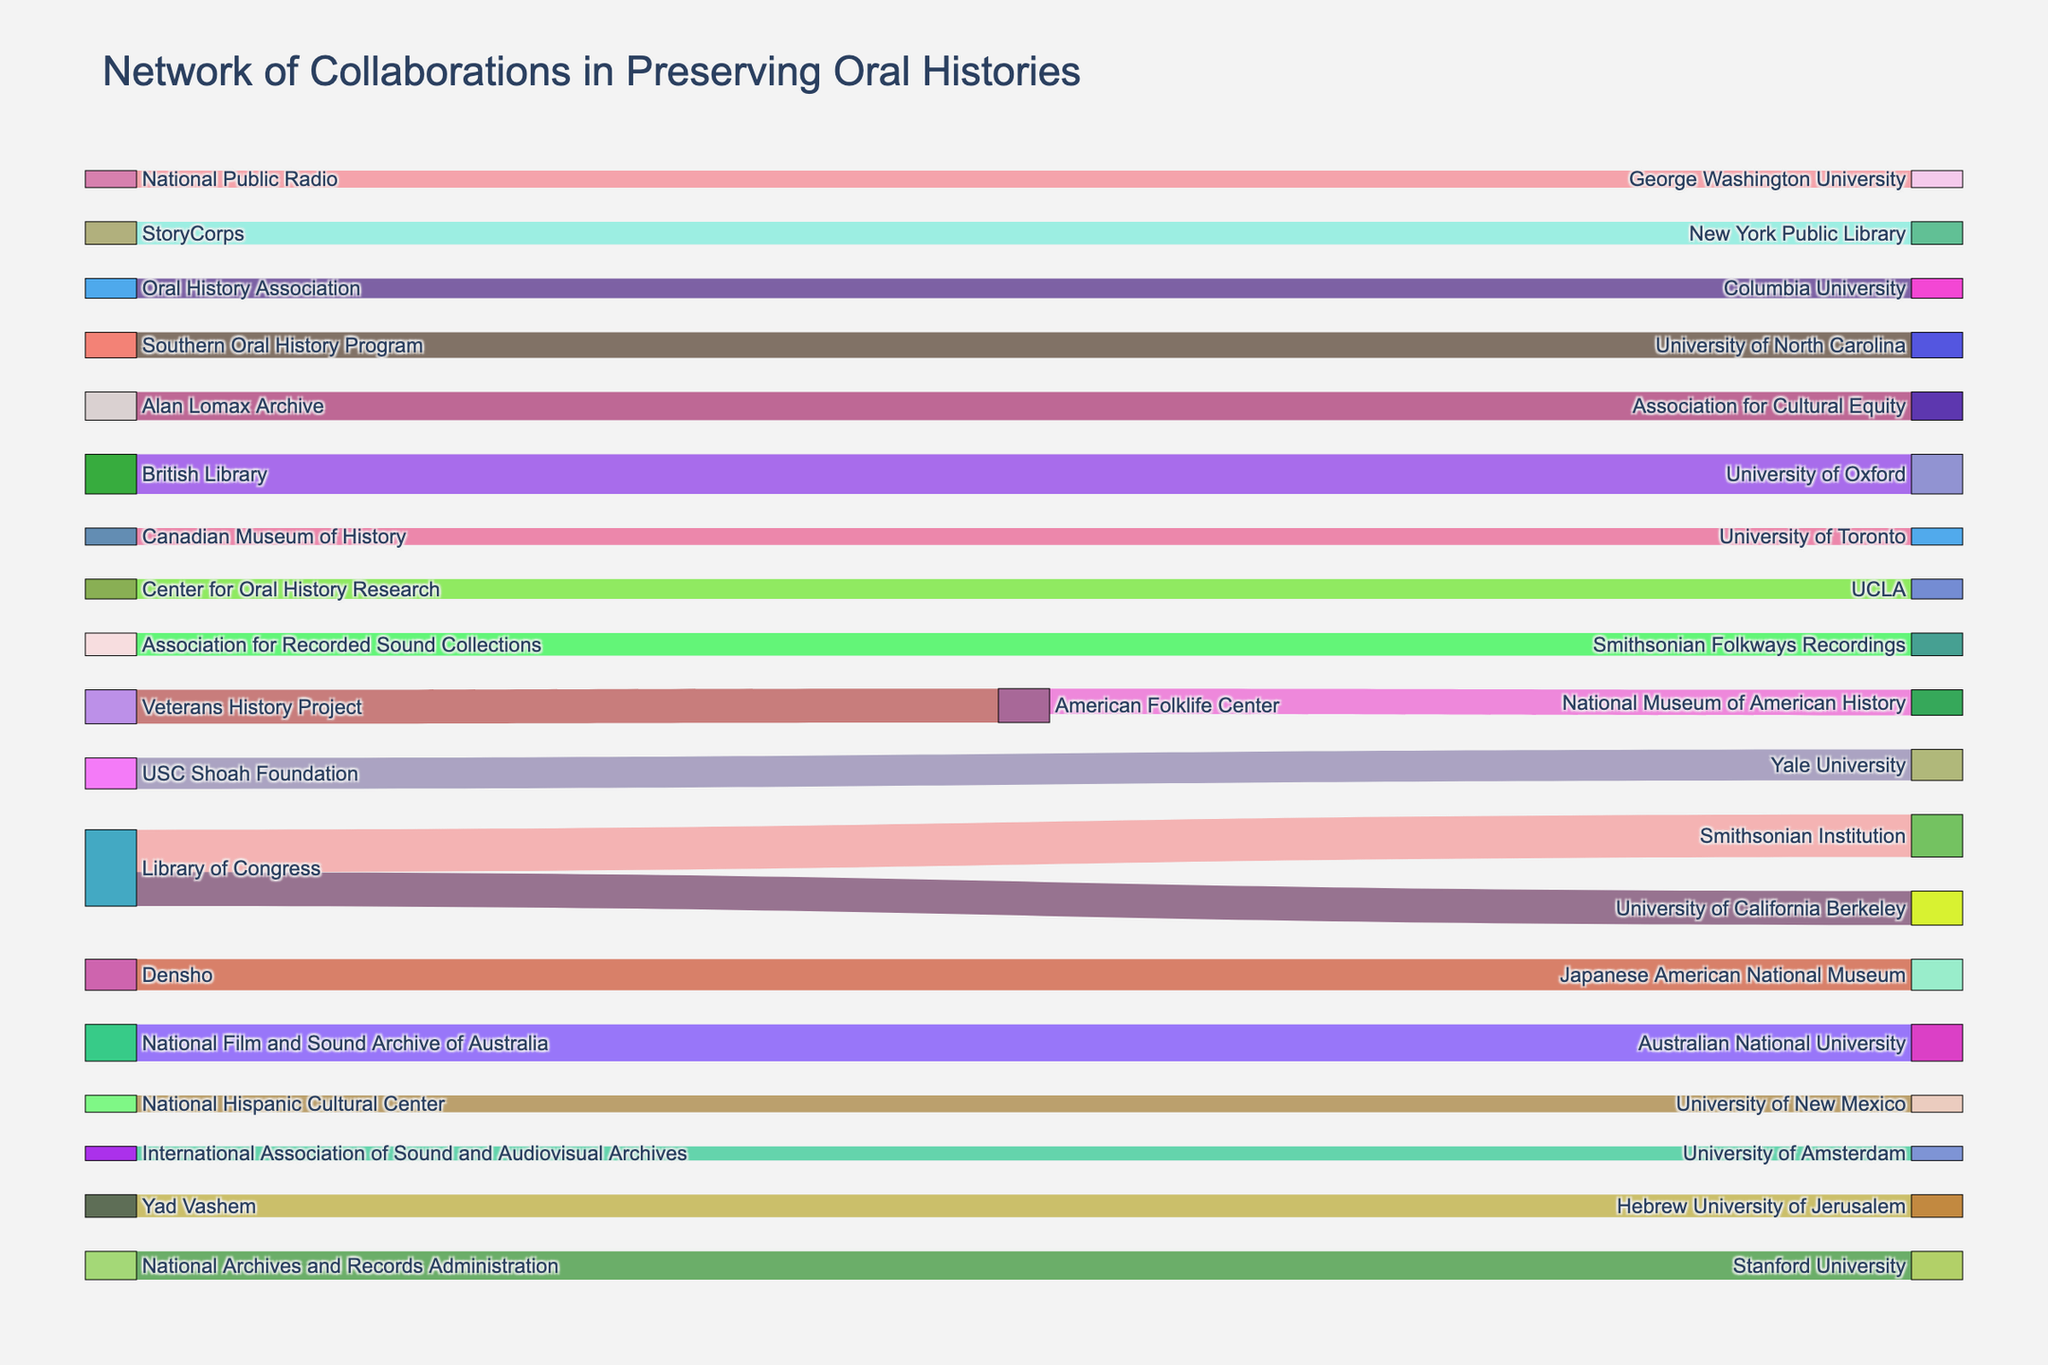what is the title of the figure? The title is written at the top of the figure as "Network of Collaborations in Preserving Oral Histories".
Answer: Network of Collaborations in Preserving Oral Histories How many connections are there from the Library of Congress? To find the number of connections from the Library of Congress, look at the nodes branching out from it. There are three connections: one to Smithsonian Institution, one to University of California Berkeley, and one to Stanford University.
Answer: 3 Which collaboration has the highest value? Look for the connection with the largest value. The highest value is 15, which corresponds to the collaboration between the Library of Congress and the Smithsonian Institution.
Answer: Library of Congress and Smithsonian Institution How much total value is contributed by StoryCorps? Sum the values of all connections from StoryCorps. StoryCorps has one connection to the New York Public Library with a value of 8.
Answer: 8 How many institutions collaborate with the Smithsonian Institution? Look for the nodes that connect to the Smithsonian Institution. There are two collaborations: one with the Library of Congress and one with the Association for Recorded Sound Collections.
Answer: 2 What's the average value of the connections involving academic institutions? Identify all connections involving academic institutions: University of California Berkeley (12), Stanford University (10), University of Oxford (14), Yale University (11), University of Toronto (6), Australian National University (13), University of Amsterdam (5), George Washington University (6), Columbia University (7), University of North Carolina (9), UCLA (7), University of New Mexico (6), Hebrew University of Jerusalem (8). Sum these values (12+10+14+11+6+13+5+6+7+9+7+6+8 = 114) and divide by the number of connections (13).
Answer: 8.77 Which organization collaborates with the George Washington University? Identify the node connected to George Washington University. National Public Radio is the organization that connects to it.
Answer: National Public Radio What's the difference in value between the collaborations involving American institutions and non-American institutions? Sum the values for American institutions: Library of Congress (15+12+10), National Archives (10), StoryCorps (8), USC Shoah Foundation (11), American Folklife Center (9+12), Oral History Association (7), National Public Radio (6), Alan Lomax Archive (10), Southern Oral History Program (9), Center for Oral History Research (7), Densho (11), National Hispanic Cultural Center (6). This gives a total of 143. Now sum the values for non-American institutions: British Library (14), Canadian Museum of History (6), National Film and Sound Archive of Australia (13), International Association of Sound and Audiovisual Archives (5), Yad Vashem (8), giving a total of 46. The difference is 143-46.
Answer: 97 